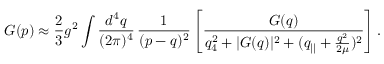<formula> <loc_0><loc_0><loc_500><loc_500>G ( p ) \approx \frac { 2 } { 3 } g ^ { 2 } \int \frac { d ^ { 4 } q } { ( 2 \pi ) ^ { 4 } } \, \frac { 1 } ( p - q ) ^ { 2 } } \left [ \frac { G ( q ) } { q _ { 4 } ^ { 2 } + | G ( q ) | ^ { 2 } + ( q _ { | | } + \frac { q ^ { 2 } } { 2 \mu } ) ^ { 2 } } \right ] .</formula> 